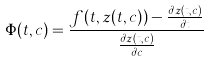Convert formula to latex. <formula><loc_0><loc_0><loc_500><loc_500>\Phi ( t , c ) = \frac { f ( t , z ( t , c ) ) - \frac { \partial z ( t , c ) } { \partial t } } { \frac { \partial z ( t , c ) } { \partial c } }</formula> 